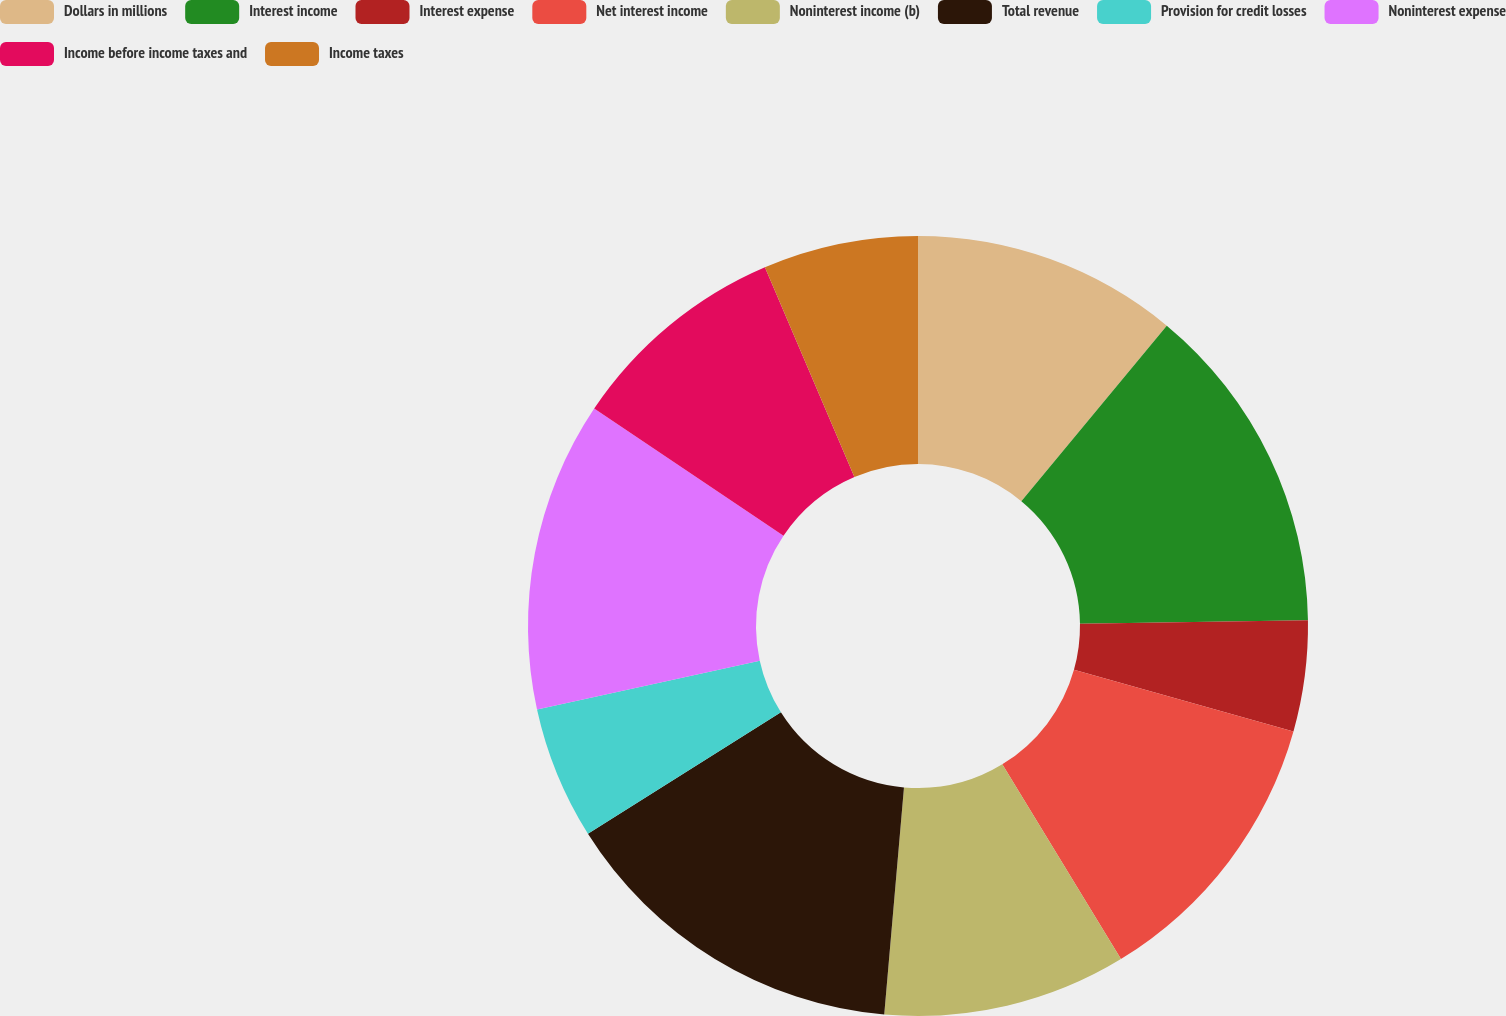Convert chart. <chart><loc_0><loc_0><loc_500><loc_500><pie_chart><fcel>Dollars in millions<fcel>Interest income<fcel>Interest expense<fcel>Net interest income<fcel>Noninterest income (b)<fcel>Total revenue<fcel>Provision for credit losses<fcel>Noninterest expense<fcel>Income before income taxes and<fcel>Income taxes<nl><fcel>11.01%<fcel>13.76%<fcel>4.59%<fcel>11.93%<fcel>10.09%<fcel>14.68%<fcel>5.51%<fcel>12.84%<fcel>9.17%<fcel>6.42%<nl></chart> 